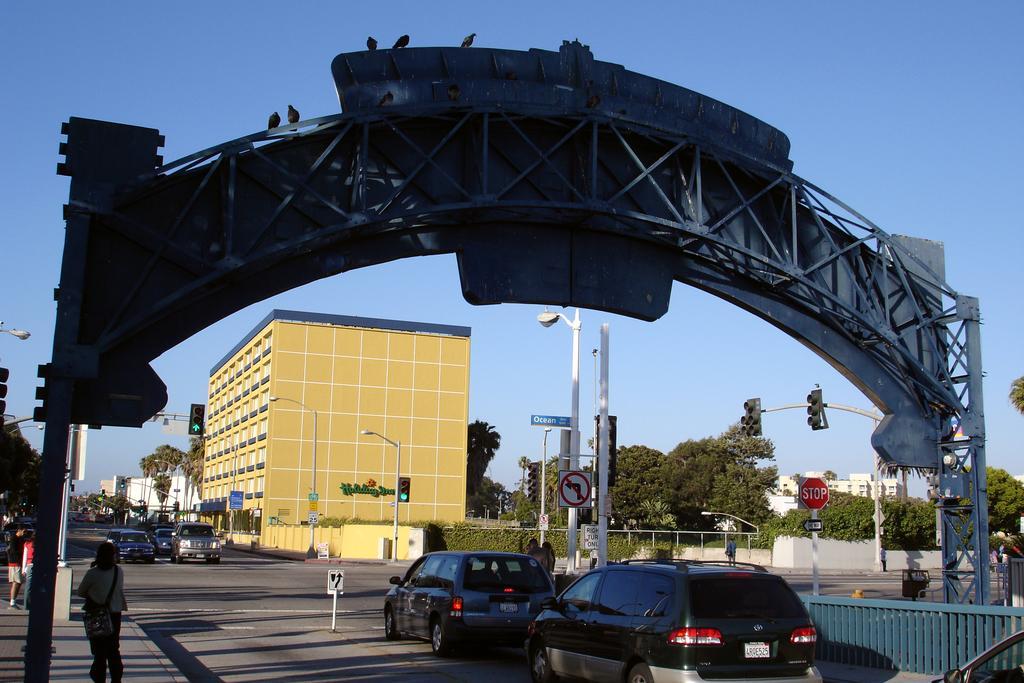Please provide a concise description of this image. In this image few vehicles are on the road. Left side few people are on the pavement. Few traffic lights are attached to the poles. Right side there is a fence. There are street lights on the pavement. Few boards are attached to the poles. Front side of the image there is an arch. Background there are trees and buildings. Top of the image there is sky. 